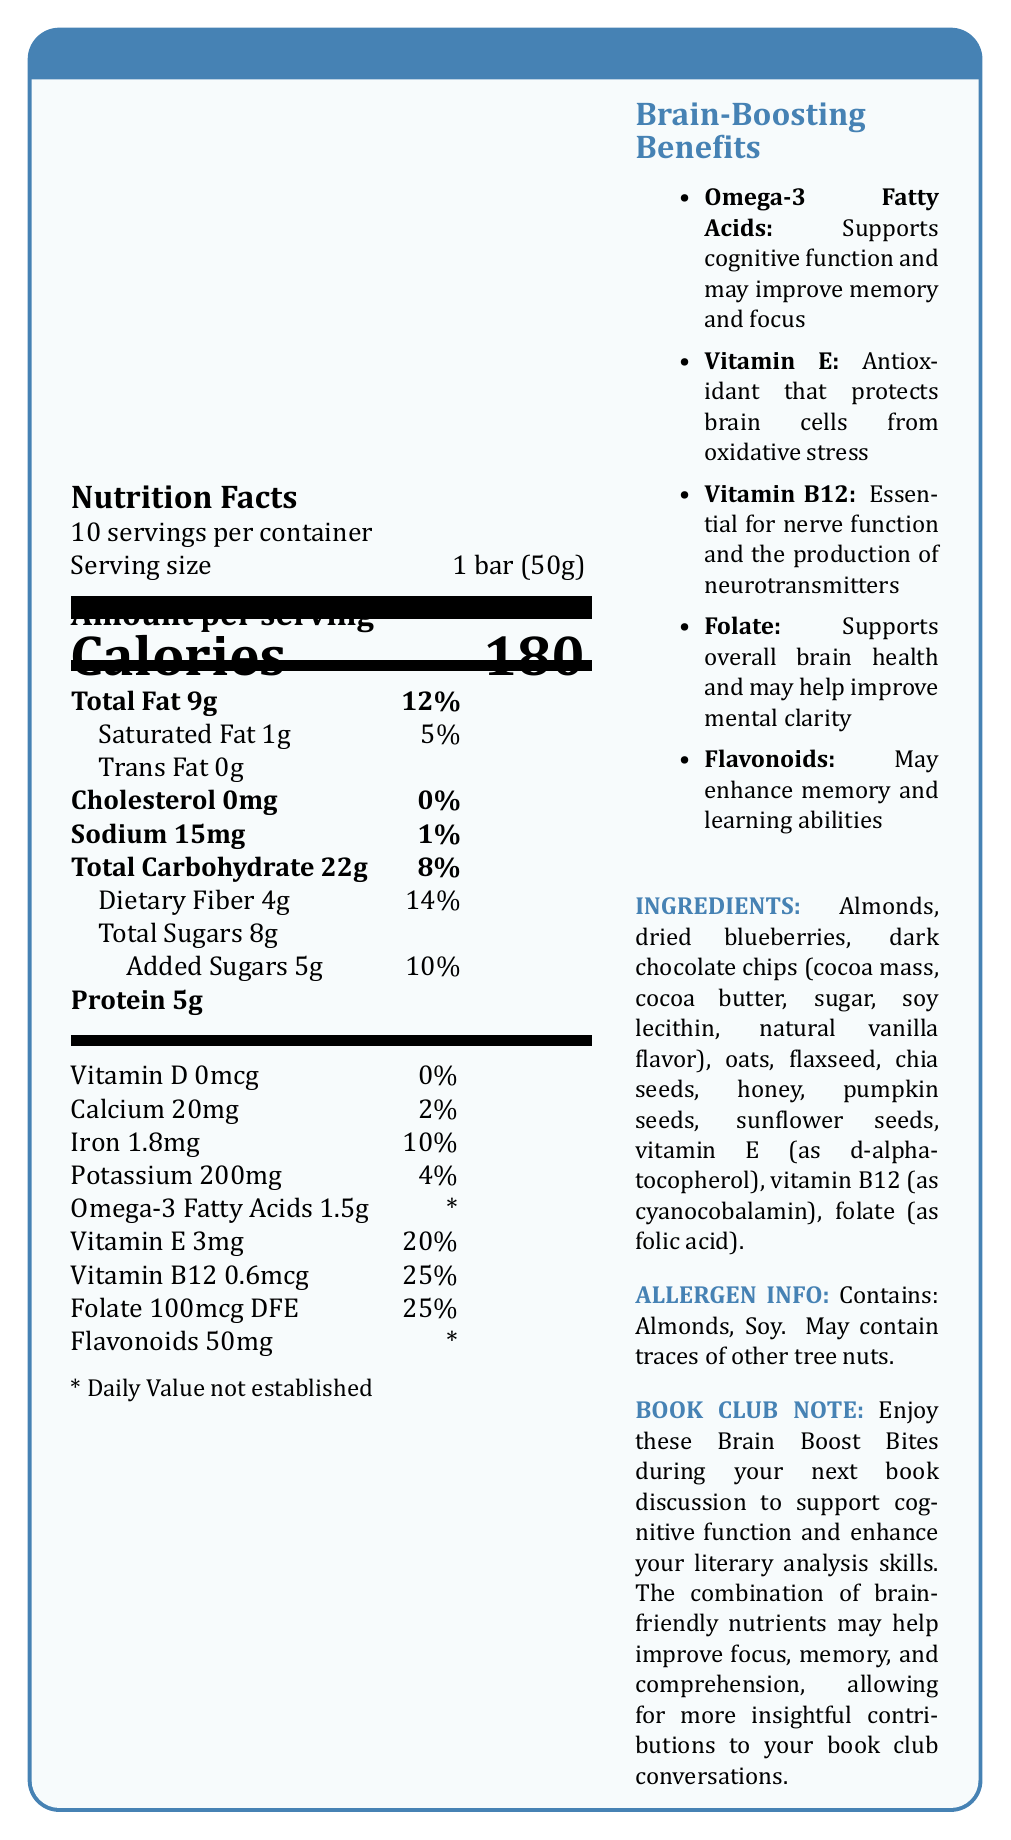what is the serving size? The document states that the serving size is 1 bar, which weighs 50 grams.
Answer: 1 bar (50g) how many servings are in a container? The document mentions that there are 10 servings per container.
Answer: 10 how much protein does one serving contain? The amount of protein per serving is listed as 5 grams in the Nutrition Facts section.
Answer: 5g what is the percentage daily value of Vitamin B12 in each serving? The document indicates that each serving provides 25% of the daily value for Vitamin B12.
Answer: 25% which ingredient is a common allergen that might concern some consumers? The allergen information section specifies that the product contains almonds and soy.
Answer: Almonds, Soy how much total fat does one serving provide? A. 5g B. 9g C. 12g D. 15g The Total Fat per serving is listed as 9 grams.
Answer: B. 9g which of the following nutrients has unspecified daily values listed? A. Omega-3 Fatty Acids B. Vitamin E C. Iron D. Folate The Nutrition Facts mention Omega-3 Fatty Acids with a daily value marked as "*", indicating it is not established.
Answer: A. Omega-3 Fatty Acids does one serving contain any cholesterol? The Nutrition Facts section states that the cholesterol content is 0mg, which means it contains no cholesterol.
Answer: No summarize the main purpose of the entire document. The document includes nutritional information, beneficial nutrients, ingredient list, allergen warnings, and a note on how the product supports cognitive functions beneficial for book club activities.
Answer: The document provides detailed nutrition information about the "Brain Boost Book Club Bites", highlighting the brain-boosting benefits of the nutrients contained in each serving, which are designed to support cognitive function and enhance reading comprehension for book club members. what is the source of flavonoids in these bites? The document mentions the amount of flavonoids and their benefits but does not specify their source.
Answer: Not enough information what are the brain-boosting benefits of Omega-3 Fatty Acids? The document lists the brain-boosting benefits of Omega-3 Fatty Acids specifically as supporting cognitive function and potentially improving memory and focus.
Answer: Supports cognitive function and may improve memory and focus how much added sugar does one bar contain? The document specifies that the total added sugars per serving are 5 grams.
Answer: 5g how much dietary fiber is in each serving? Each serving contains 4 grams of dietary fiber, as mentioned in the Nutrition Facts section.
Answer: 4g how does Vitamin E benefit brain health? The document lists Vitamin E's brain-boosting benefit as an antioxidant that protects brain cells from oxidative stress.
Answer: Antioxidant that protects brain cells from oxidative stress is there any folate in each serving? The document states that each serving contains 100mcg DFE of folate, which is 25% of the daily value.
Answer: Yes 